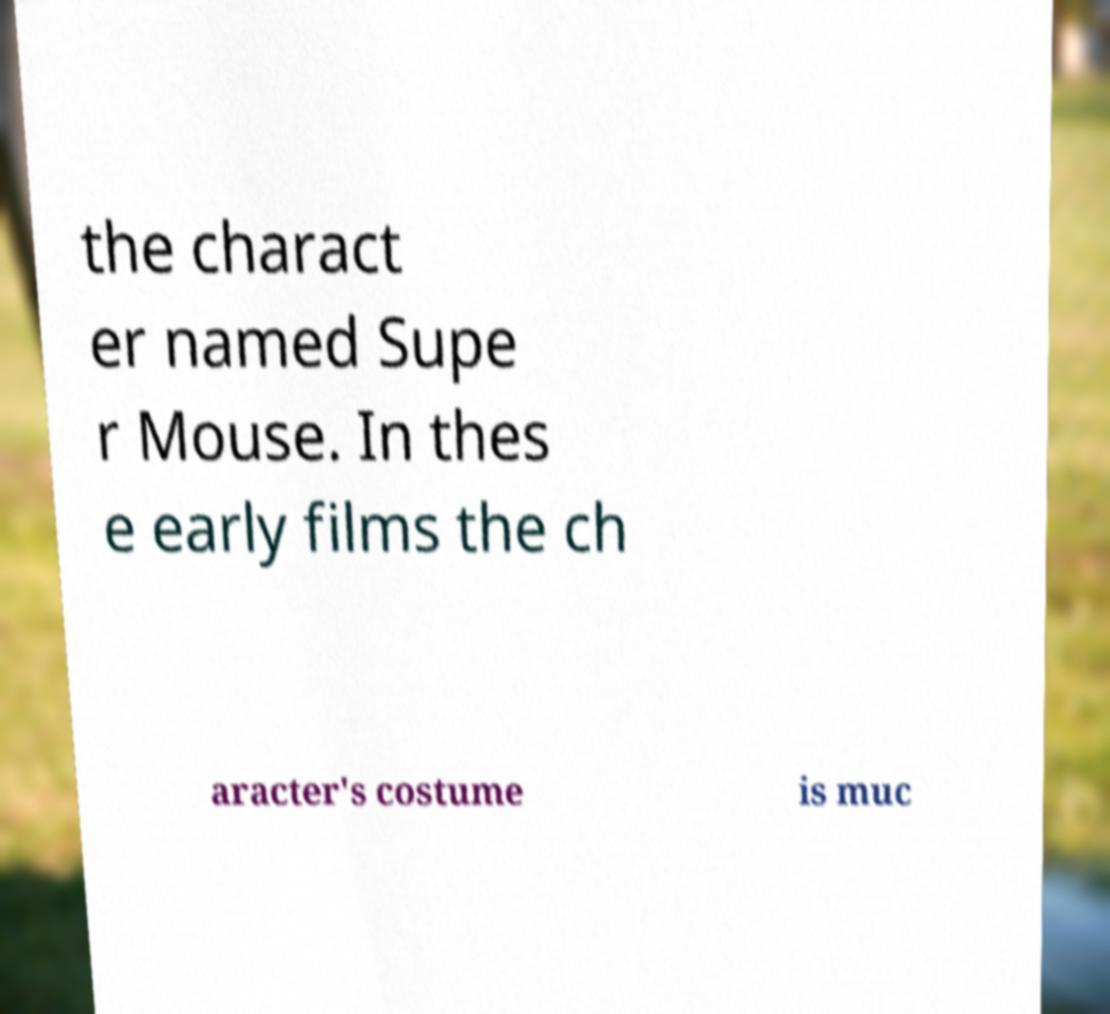I need the written content from this picture converted into text. Can you do that? the charact er named Supe r Mouse. In thes e early films the ch aracter's costume is muc 